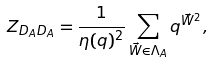Convert formula to latex. <formula><loc_0><loc_0><loc_500><loc_500>Z _ { D _ { A } D _ { A } } = \frac { 1 } { \eta ( q ) ^ { 2 } } \sum _ { \vec { W } \in \Lambda _ { A } } q ^ { \vec { W } ^ { 2 } } ,</formula> 